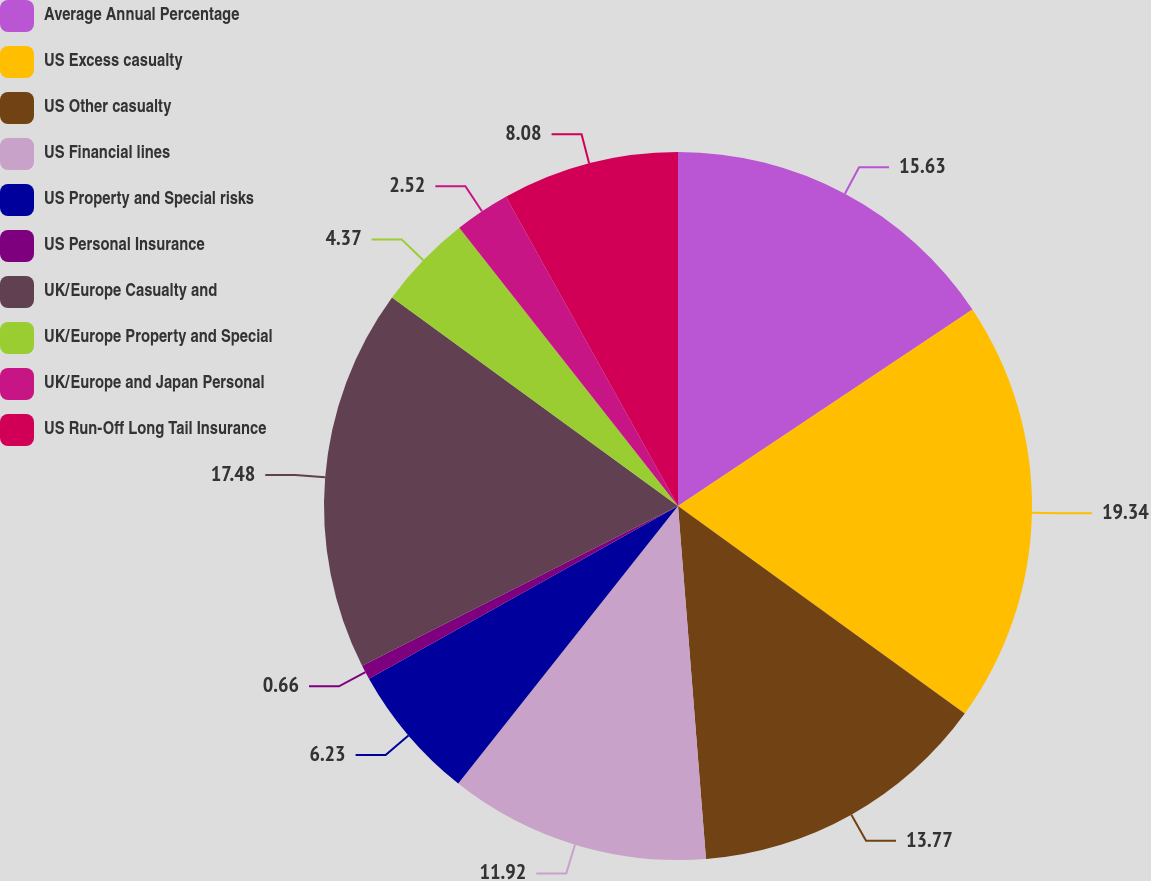<chart> <loc_0><loc_0><loc_500><loc_500><pie_chart><fcel>Average Annual Percentage<fcel>US Excess casualty<fcel>US Other casualty<fcel>US Financial lines<fcel>US Property and Special risks<fcel>US Personal Insurance<fcel>UK/Europe Casualty and<fcel>UK/Europe Property and Special<fcel>UK/Europe and Japan Personal<fcel>US Run-Off Long Tail Insurance<nl><fcel>15.63%<fcel>19.34%<fcel>13.77%<fcel>11.92%<fcel>6.23%<fcel>0.66%<fcel>17.48%<fcel>4.37%<fcel>2.52%<fcel>8.08%<nl></chart> 